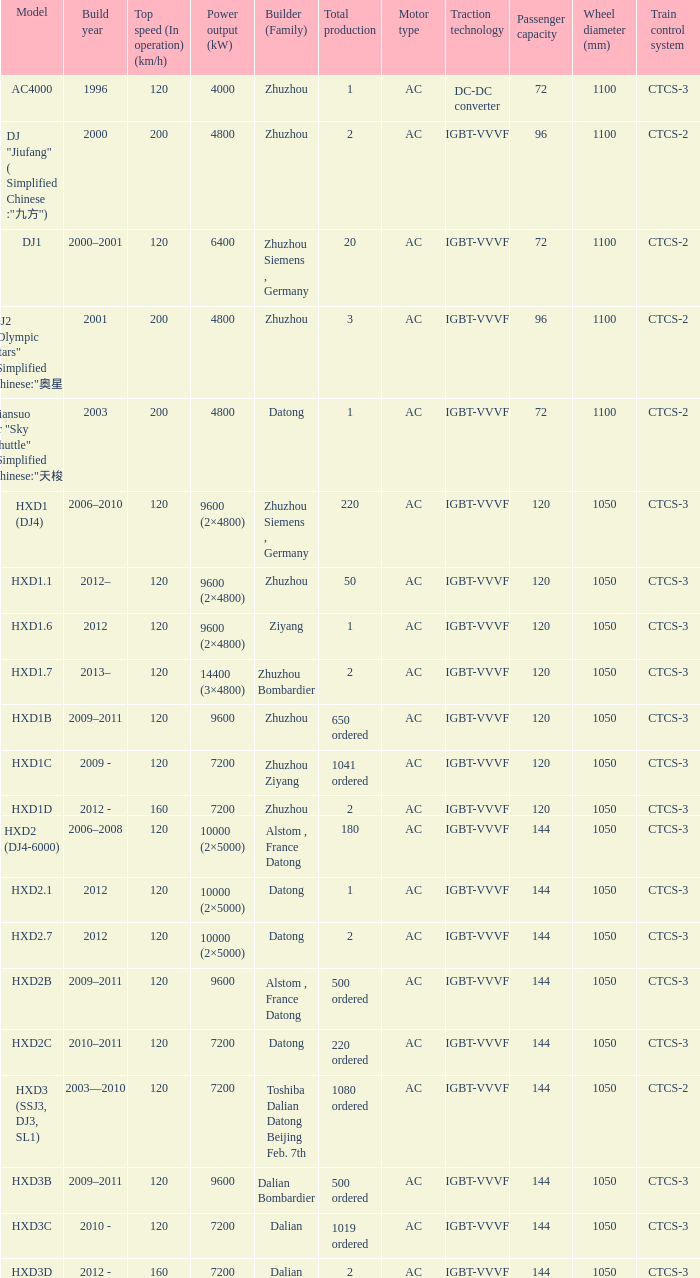What model has a builder of zhuzhou, and a power output of 9600 (kw)? HXD1B. 